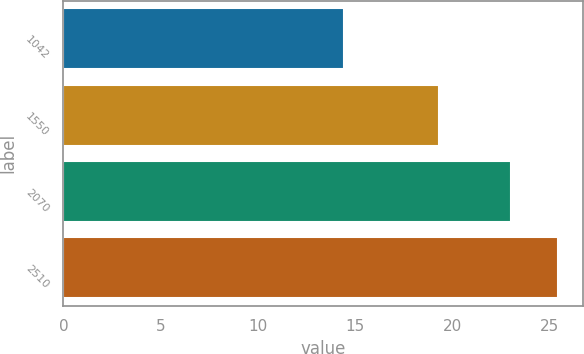<chart> <loc_0><loc_0><loc_500><loc_500><bar_chart><fcel>1042<fcel>1550<fcel>2070<fcel>2510<nl><fcel>14.45<fcel>19.33<fcel>23.02<fcel>25.44<nl></chart> 